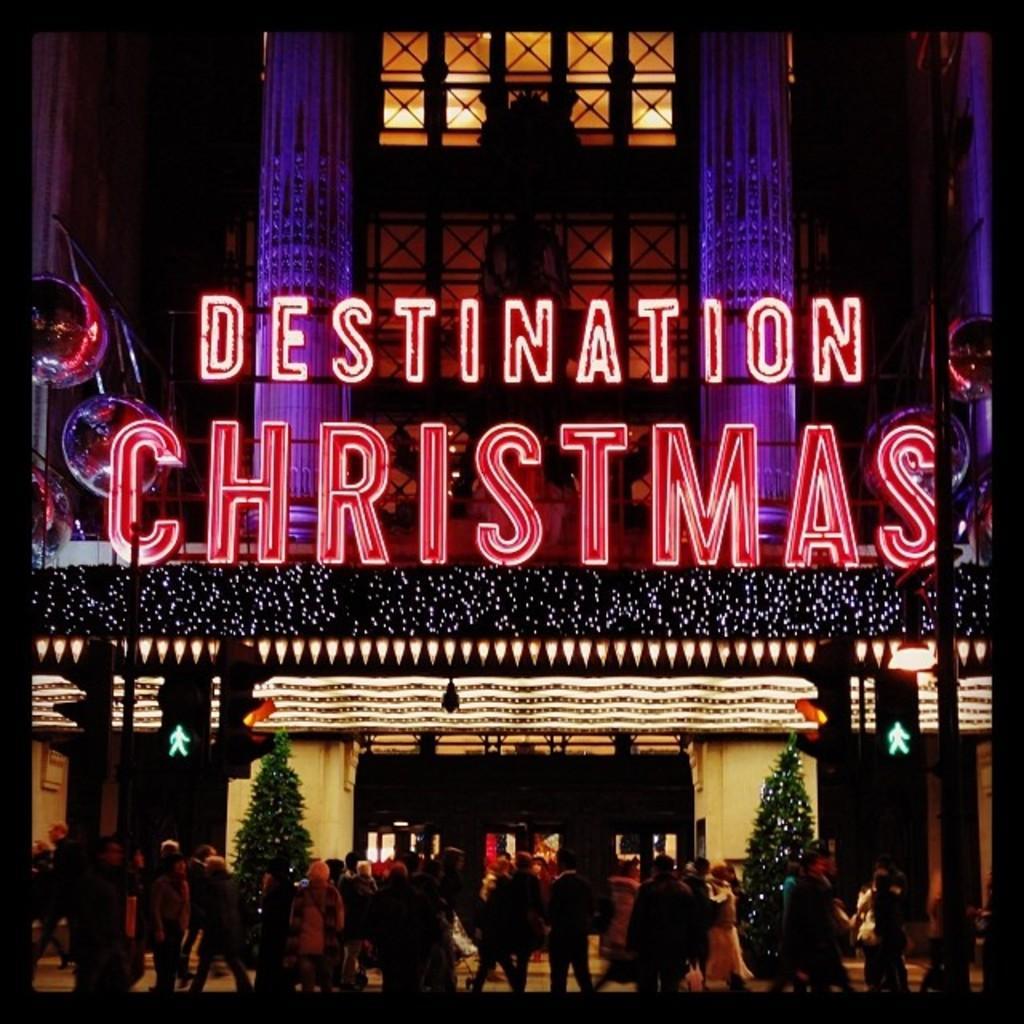In one or two sentences, can you explain what this image depicts? Here in this picture we can see a building present over there and it is decorated with lights and hoarding and on the road we can see people standing and walking here and there and we can see Christmas trees here and there and we can see traffic signal lights on the pole over there. 